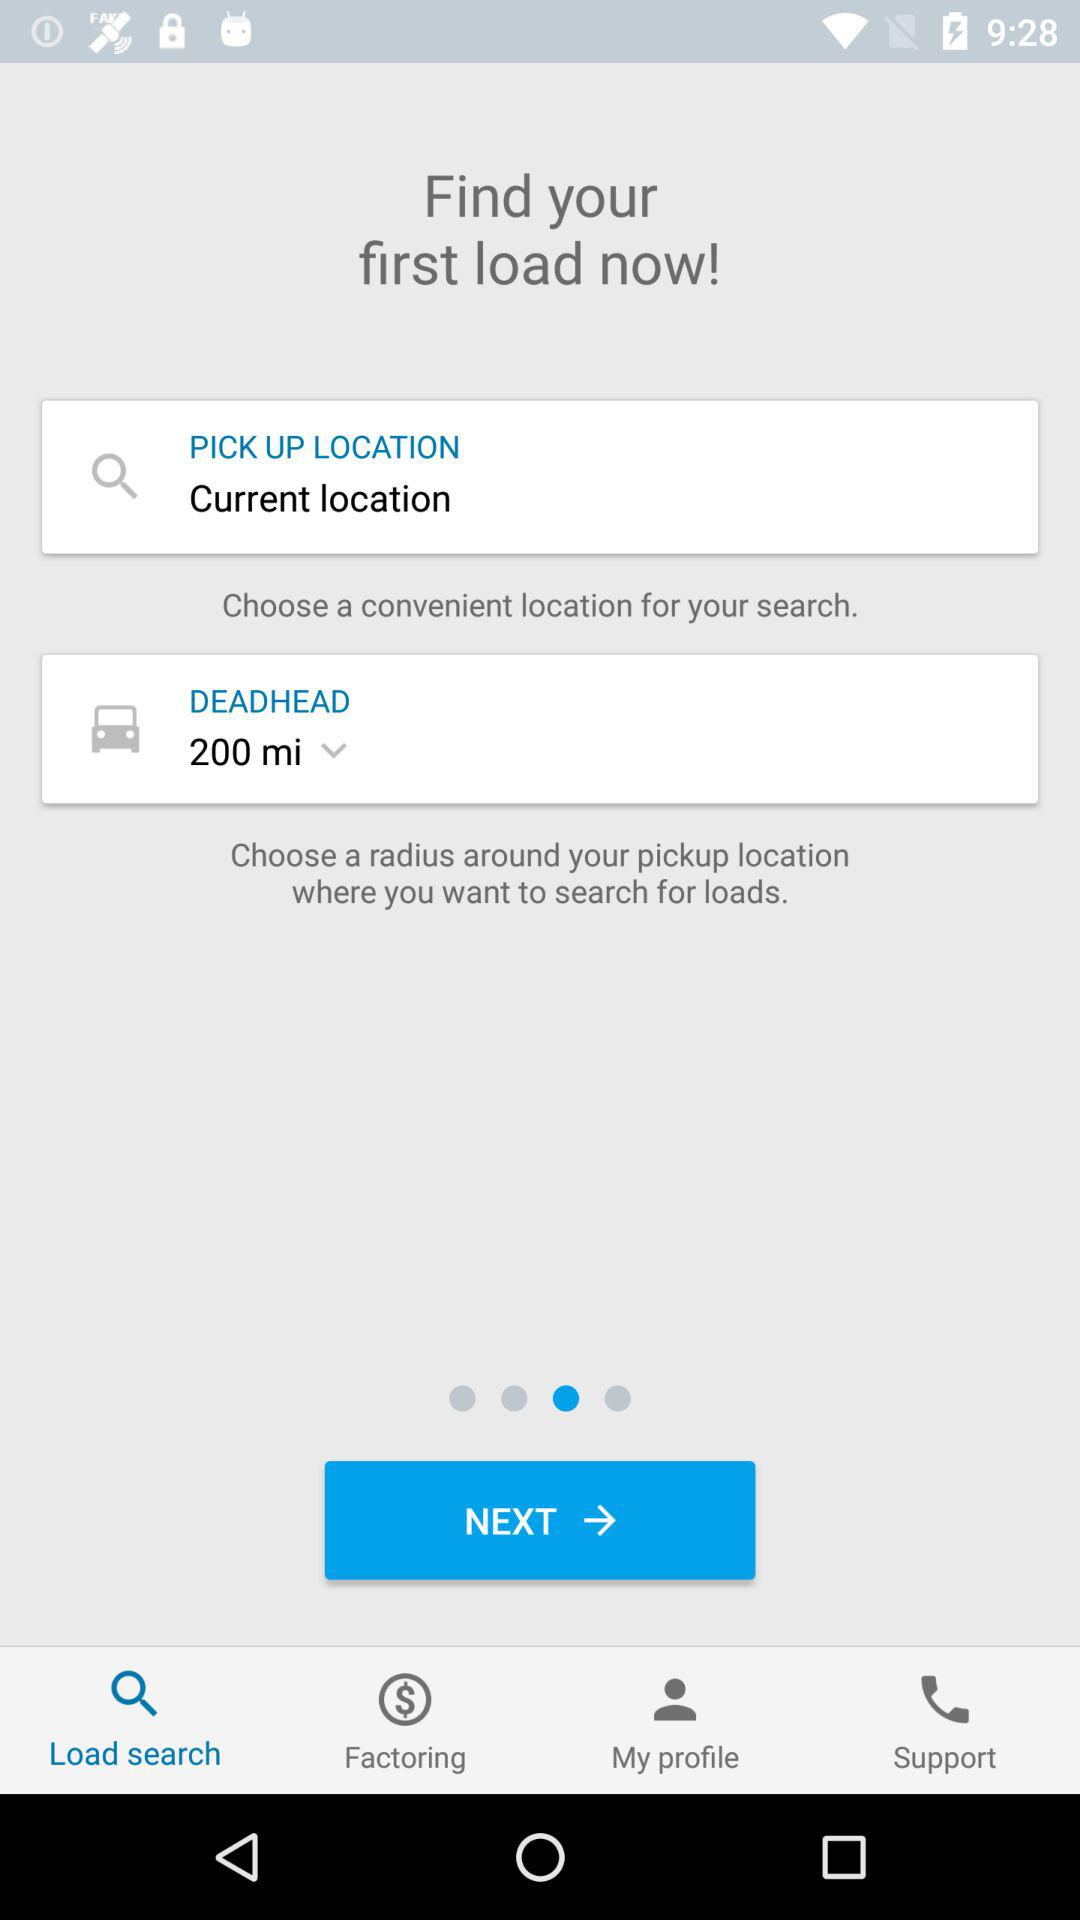Which option is selected? The selected option is "Load search". 